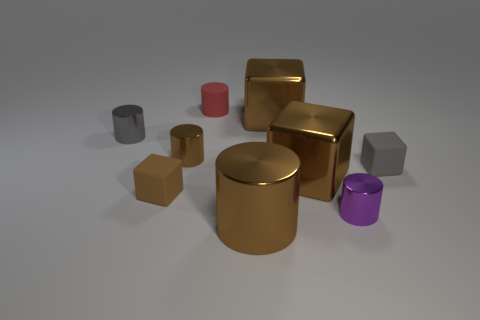Does the large brown metal thing that is behind the tiny gray cylinder have the same shape as the small matte thing left of the small matte cylinder?
Your answer should be compact. Yes. What number of other things are there of the same material as the big cylinder
Offer a very short reply. 5. There is a metal cube that is right of the cube behind the gray metal object; is there a small gray thing behind it?
Make the answer very short. Yes. Do the red cylinder and the big brown cylinder have the same material?
Offer a terse response. No. What material is the brown thing that is behind the brown cylinder on the left side of the small red matte cylinder?
Your answer should be very brief. Metal. There is a metal block that is behind the tiny gray metallic cylinder; how big is it?
Provide a succinct answer. Large. There is a large object that is both in front of the tiny gray block and behind the purple cylinder; what is its color?
Keep it short and to the point. Brown. There is a gray object that is on the left side of the rubber cylinder; does it have the same size as the small red thing?
Provide a short and direct response. Yes. There is a tiny cylinder that is in front of the gray matte block; is there a small thing that is on the right side of it?
Your answer should be very brief. Yes. What material is the red cylinder?
Make the answer very short. Rubber. 